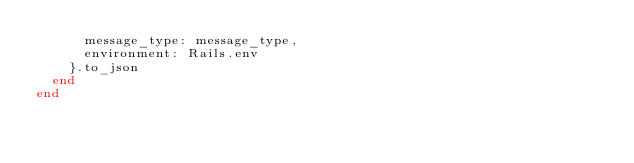Convert code to text. <code><loc_0><loc_0><loc_500><loc_500><_Ruby_>      message_type: message_type,
      environment: Rails.env
    }.to_json
  end
end
</code> 